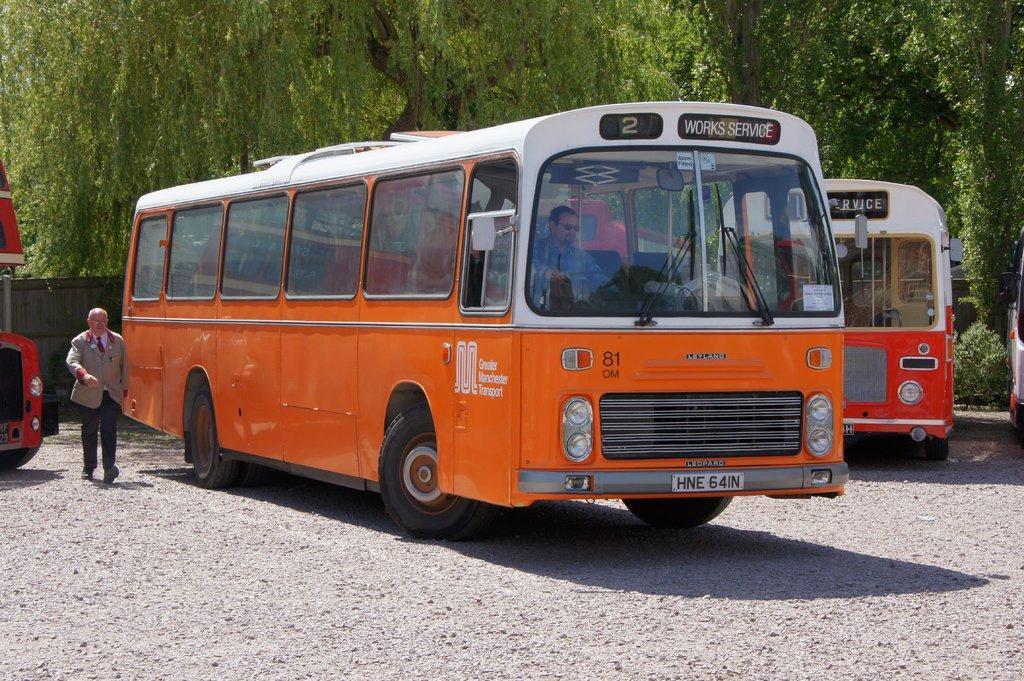In one or two sentences, can you explain what this image depicts? In the picture there are two buses and on the left side there is some other vehicle, beside the vehicle there is a man walking on the ground. In the background there are many trees. 